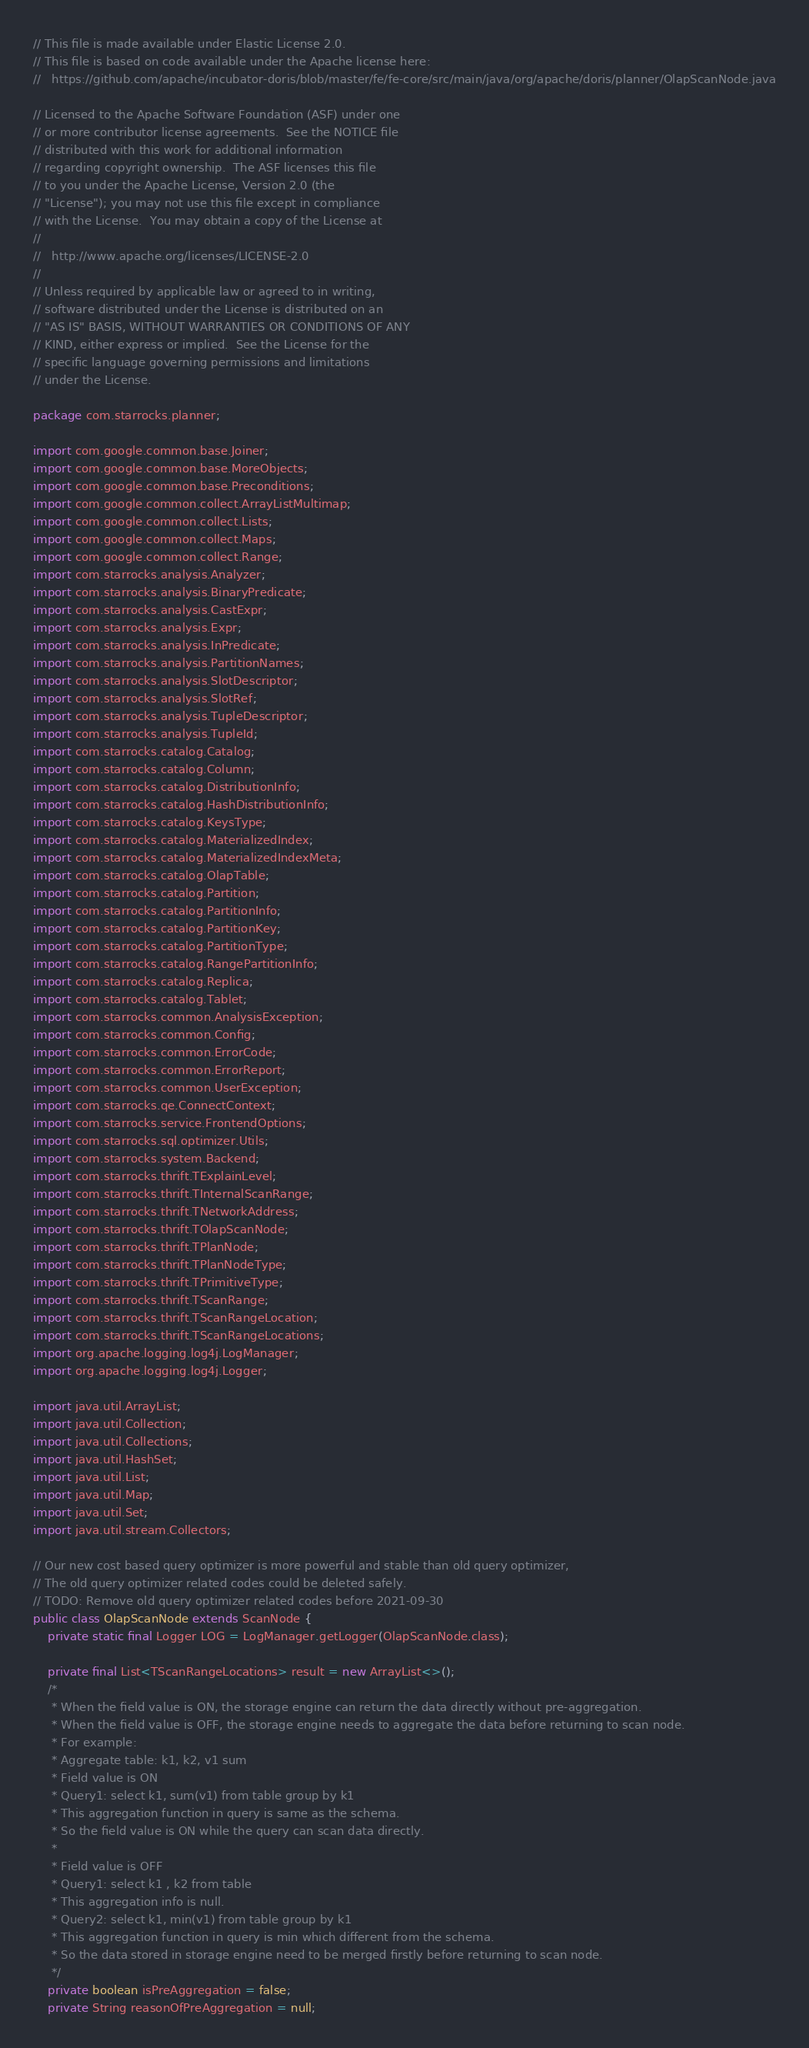Convert code to text. <code><loc_0><loc_0><loc_500><loc_500><_Java_>// This file is made available under Elastic License 2.0.
// This file is based on code available under the Apache license here:
//   https://github.com/apache/incubator-doris/blob/master/fe/fe-core/src/main/java/org/apache/doris/planner/OlapScanNode.java

// Licensed to the Apache Software Foundation (ASF) under one
// or more contributor license agreements.  See the NOTICE file
// distributed with this work for additional information
// regarding copyright ownership.  The ASF licenses this file
// to you under the Apache License, Version 2.0 (the
// "License"); you may not use this file except in compliance
// with the License.  You may obtain a copy of the License at
//
//   http://www.apache.org/licenses/LICENSE-2.0
//
// Unless required by applicable law or agreed to in writing,
// software distributed under the License is distributed on an
// "AS IS" BASIS, WITHOUT WARRANTIES OR CONDITIONS OF ANY
// KIND, either express or implied.  See the License for the
// specific language governing permissions and limitations
// under the License.

package com.starrocks.planner;

import com.google.common.base.Joiner;
import com.google.common.base.MoreObjects;
import com.google.common.base.Preconditions;
import com.google.common.collect.ArrayListMultimap;
import com.google.common.collect.Lists;
import com.google.common.collect.Maps;
import com.google.common.collect.Range;
import com.starrocks.analysis.Analyzer;
import com.starrocks.analysis.BinaryPredicate;
import com.starrocks.analysis.CastExpr;
import com.starrocks.analysis.Expr;
import com.starrocks.analysis.InPredicate;
import com.starrocks.analysis.PartitionNames;
import com.starrocks.analysis.SlotDescriptor;
import com.starrocks.analysis.SlotRef;
import com.starrocks.analysis.TupleDescriptor;
import com.starrocks.analysis.TupleId;
import com.starrocks.catalog.Catalog;
import com.starrocks.catalog.Column;
import com.starrocks.catalog.DistributionInfo;
import com.starrocks.catalog.HashDistributionInfo;
import com.starrocks.catalog.KeysType;
import com.starrocks.catalog.MaterializedIndex;
import com.starrocks.catalog.MaterializedIndexMeta;
import com.starrocks.catalog.OlapTable;
import com.starrocks.catalog.Partition;
import com.starrocks.catalog.PartitionInfo;
import com.starrocks.catalog.PartitionKey;
import com.starrocks.catalog.PartitionType;
import com.starrocks.catalog.RangePartitionInfo;
import com.starrocks.catalog.Replica;
import com.starrocks.catalog.Tablet;
import com.starrocks.common.AnalysisException;
import com.starrocks.common.Config;
import com.starrocks.common.ErrorCode;
import com.starrocks.common.ErrorReport;
import com.starrocks.common.UserException;
import com.starrocks.qe.ConnectContext;
import com.starrocks.service.FrontendOptions;
import com.starrocks.sql.optimizer.Utils;
import com.starrocks.system.Backend;
import com.starrocks.thrift.TExplainLevel;
import com.starrocks.thrift.TInternalScanRange;
import com.starrocks.thrift.TNetworkAddress;
import com.starrocks.thrift.TOlapScanNode;
import com.starrocks.thrift.TPlanNode;
import com.starrocks.thrift.TPlanNodeType;
import com.starrocks.thrift.TPrimitiveType;
import com.starrocks.thrift.TScanRange;
import com.starrocks.thrift.TScanRangeLocation;
import com.starrocks.thrift.TScanRangeLocations;
import org.apache.logging.log4j.LogManager;
import org.apache.logging.log4j.Logger;

import java.util.ArrayList;
import java.util.Collection;
import java.util.Collections;
import java.util.HashSet;
import java.util.List;
import java.util.Map;
import java.util.Set;
import java.util.stream.Collectors;

// Our new cost based query optimizer is more powerful and stable than old query optimizer,
// The old query optimizer related codes could be deleted safely.
// TODO: Remove old query optimizer related codes before 2021-09-30
public class OlapScanNode extends ScanNode {
    private static final Logger LOG = LogManager.getLogger(OlapScanNode.class);

    private final List<TScanRangeLocations> result = new ArrayList<>();
    /*
     * When the field value is ON, the storage engine can return the data directly without pre-aggregation.
     * When the field value is OFF, the storage engine needs to aggregate the data before returning to scan node.
     * For example:
     * Aggregate table: k1, k2, v1 sum
     * Field value is ON
     * Query1: select k1, sum(v1) from table group by k1
     * This aggregation function in query is same as the schema.
     * So the field value is ON while the query can scan data directly.
     *
     * Field value is OFF
     * Query1: select k1 , k2 from table
     * This aggregation info is null.
     * Query2: select k1, min(v1) from table group by k1
     * This aggregation function in query is min which different from the schema.
     * So the data stored in storage engine need to be merged firstly before returning to scan node.
     */
    private boolean isPreAggregation = false;
    private String reasonOfPreAggregation = null;</code> 